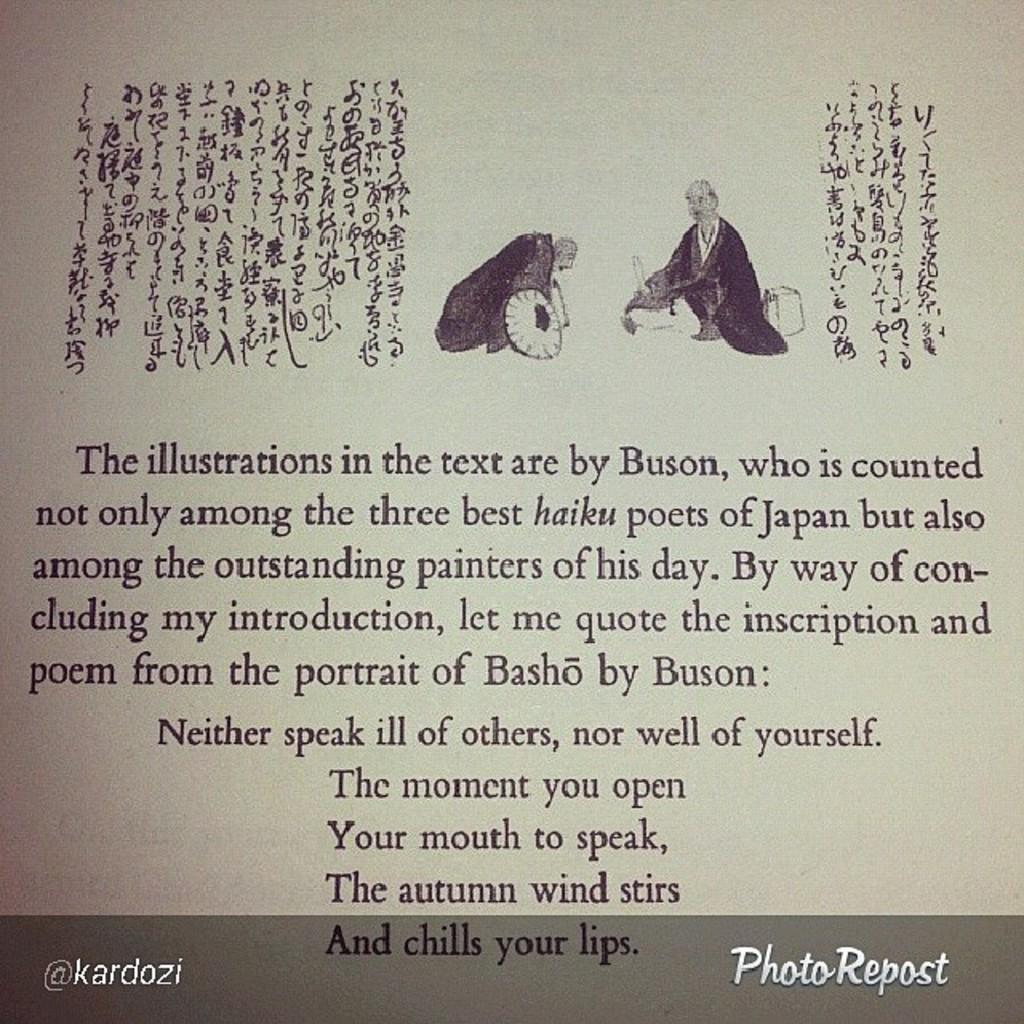<image>
Relay a brief, clear account of the picture shown. Buson, who drew the illustrations in the text, is among the three best haiku poets of Japan. 